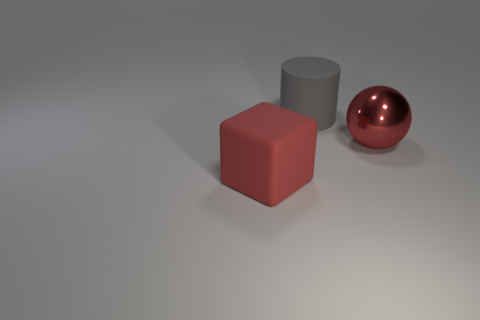Subtract all purple cubes. Subtract all green balls. How many cubes are left? 1 Add 2 small gray matte spheres. How many objects exist? 5 Subtract all cylinders. How many objects are left? 2 Subtract 0 gray spheres. How many objects are left? 3 Subtract all big gray rubber objects. Subtract all small cyan shiny balls. How many objects are left? 2 Add 1 large metallic balls. How many large metallic balls are left? 2 Add 1 cyan objects. How many cyan objects exist? 1 